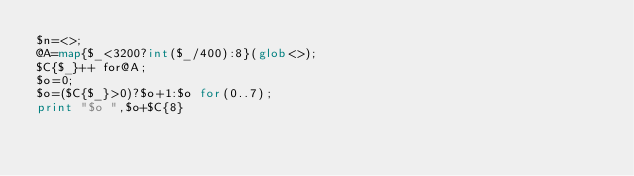<code> <loc_0><loc_0><loc_500><loc_500><_Perl_>$n=<>;
@A=map{$_<3200?int($_/400):8}(glob<>);
$C{$_}++ for@A;
$o=0;
$o=($C{$_}>0)?$o+1:$o for(0..7);
print "$o ",$o+$C{8}</code> 